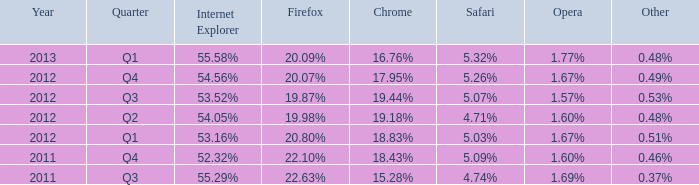Which other option has a 20.80% share similar to firefox? 0.51%. 